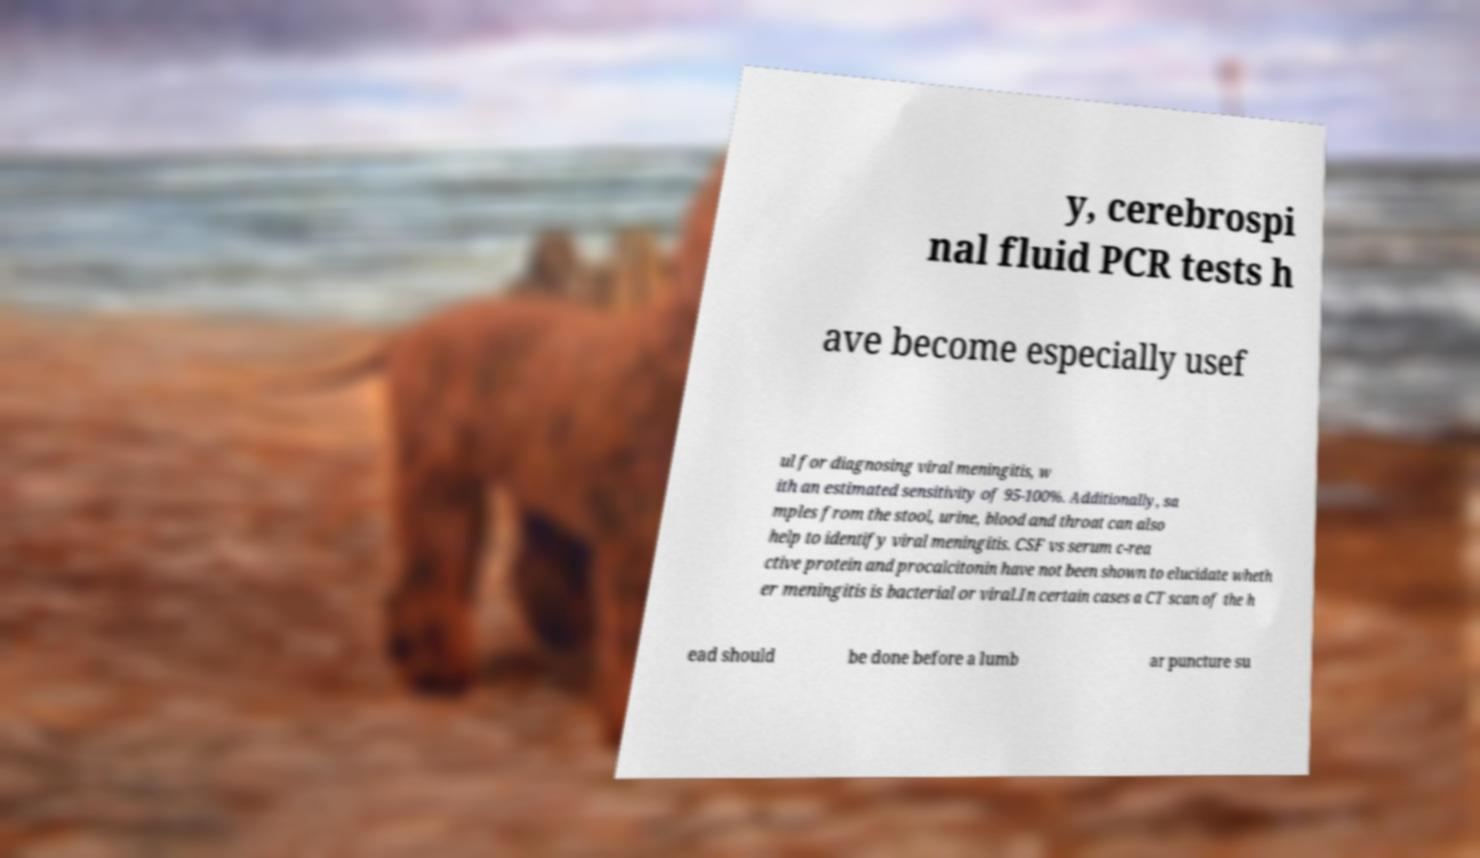Please read and relay the text visible in this image. What does it say? y, cerebrospi nal fluid PCR tests h ave become especially usef ul for diagnosing viral meningitis, w ith an estimated sensitivity of 95-100%. Additionally, sa mples from the stool, urine, blood and throat can also help to identify viral meningitis. CSF vs serum c-rea ctive protein and procalcitonin have not been shown to elucidate wheth er meningitis is bacterial or viral.In certain cases a CT scan of the h ead should be done before a lumb ar puncture su 